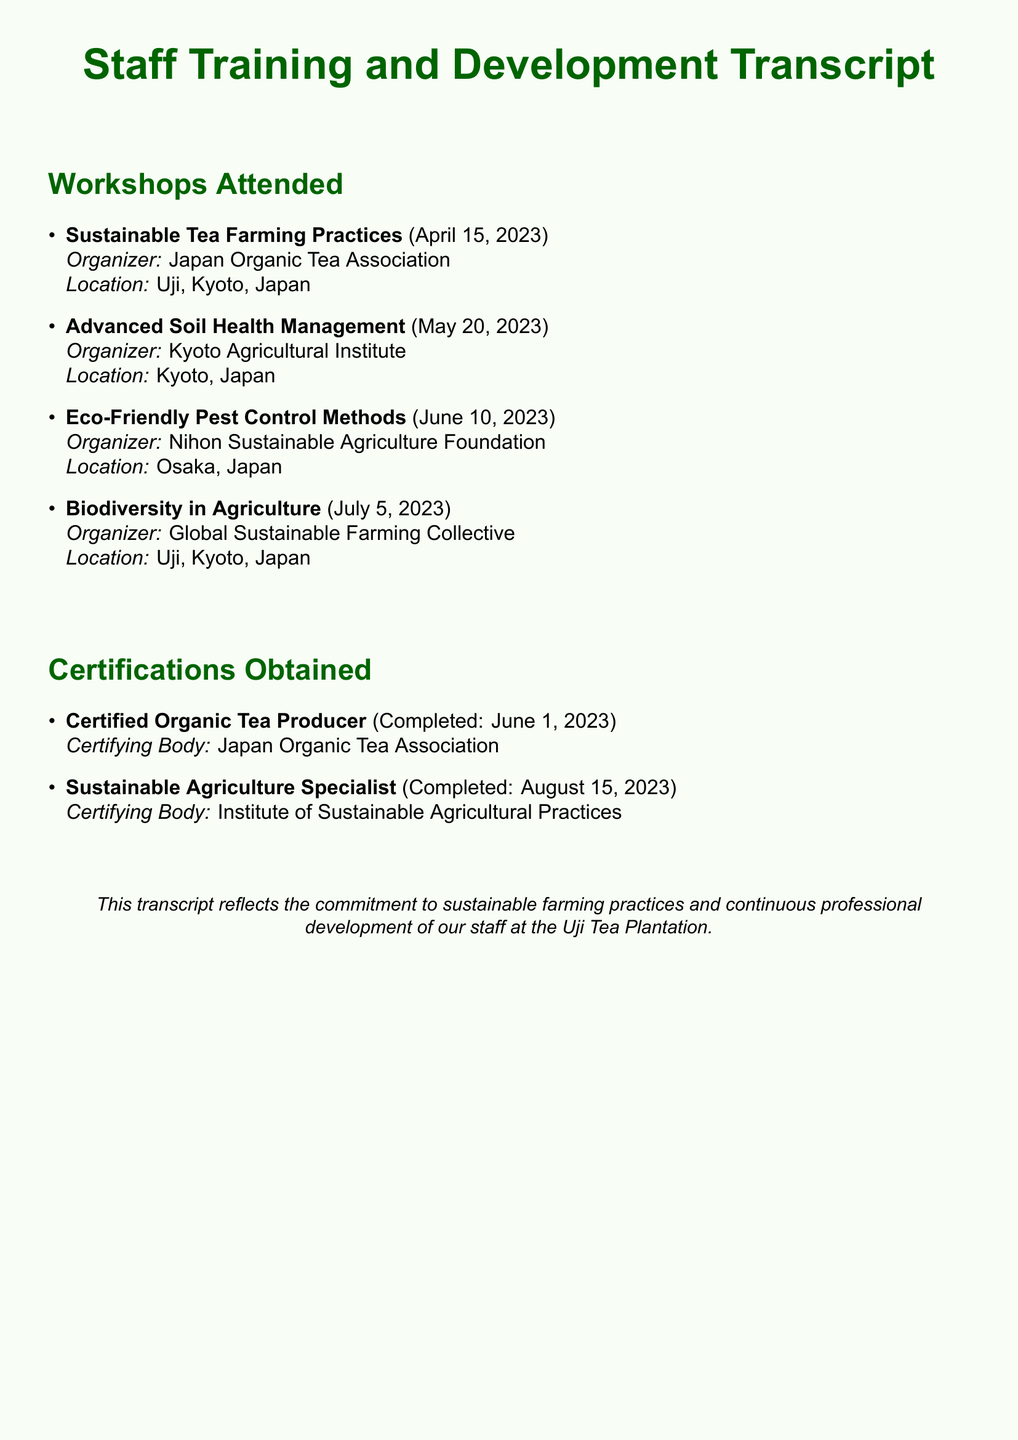What is the title of the first workshop attended? The title of the first workshop is listed as "Sustainable Tea Farming Practices."
Answer: Sustainable Tea Farming Practices When was the workshop on Eco-Friendly Pest Control Methods held? The date of the Eco-Friendly Pest Control Methods workshop is noted in the document as June 10, 2023.
Answer: June 10, 2023 Who organized the Advanced Soil Health Management workshop? The document specifies that the Advanced Soil Health Management workshop was organized by the Kyoto Agricultural Institute.
Answer: Kyoto Agricultural Institute How many certifications were obtained by the staff? The total number of certifications is counted from the document, which lists two certifications.
Answer: 2 What is the name of the certifying body for the Certified Organic Tea Producer certification? The document indicates that the certifying body for this certification is the Japan Organic Tea Association.
Answer: Japan Organic Tea Association Which workshop focused on biodiversity? The document shows that the workshop titled "Biodiversity in Agriculture" focused on biodiversity.
Answer: Biodiversity in Agriculture What is the date of completion for the Sustainable Agriculture Specialist certification? The completion date for this certification is documented as August 15, 2023.
Answer: August 15, 2023 Where was the last workshop held? The document states that the last workshop, Biodiversity in Agriculture, was held in Uji, Kyoto, Japan.
Answer: Uji, Kyoto, Japan 